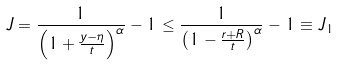Convert formula to latex. <formula><loc_0><loc_0><loc_500><loc_500>J = \frac { 1 } { \left ( 1 + \frac { y - \eta } { t } \right ) ^ { \alpha } } - 1 \leq \frac { 1 } { \left ( 1 - \frac { r + R } { t } \right ) ^ { \alpha } } - 1 \equiv J _ { 1 }</formula> 